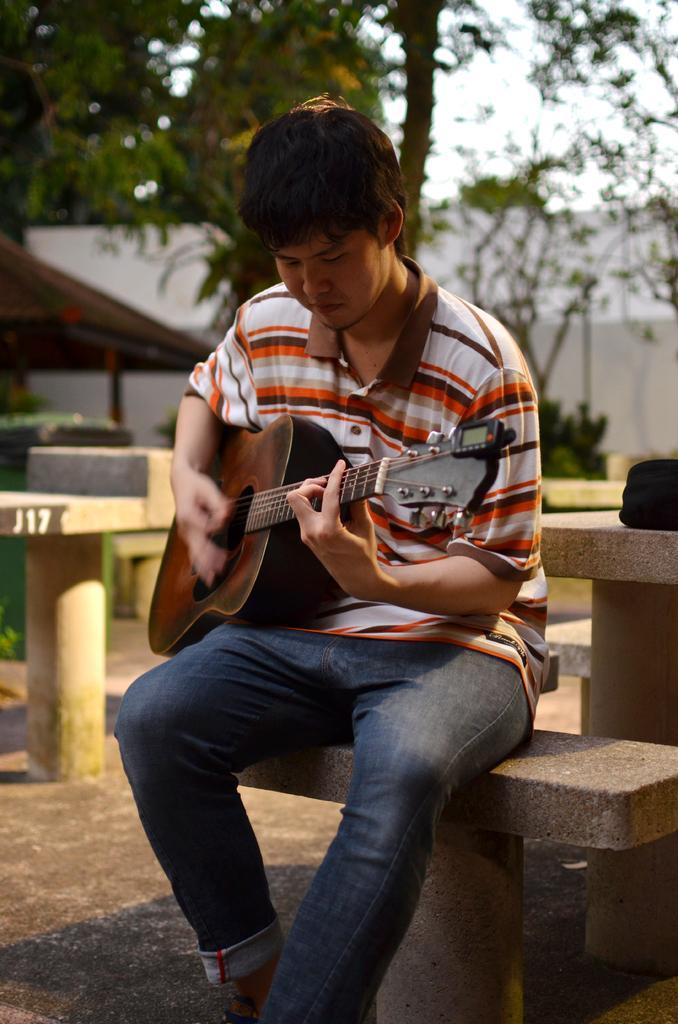Describe this image in one or two sentences. He is sitting on a chair. He is playing a guitar. He is wearing a check shirt. We can see in background trees,sky and wall. 